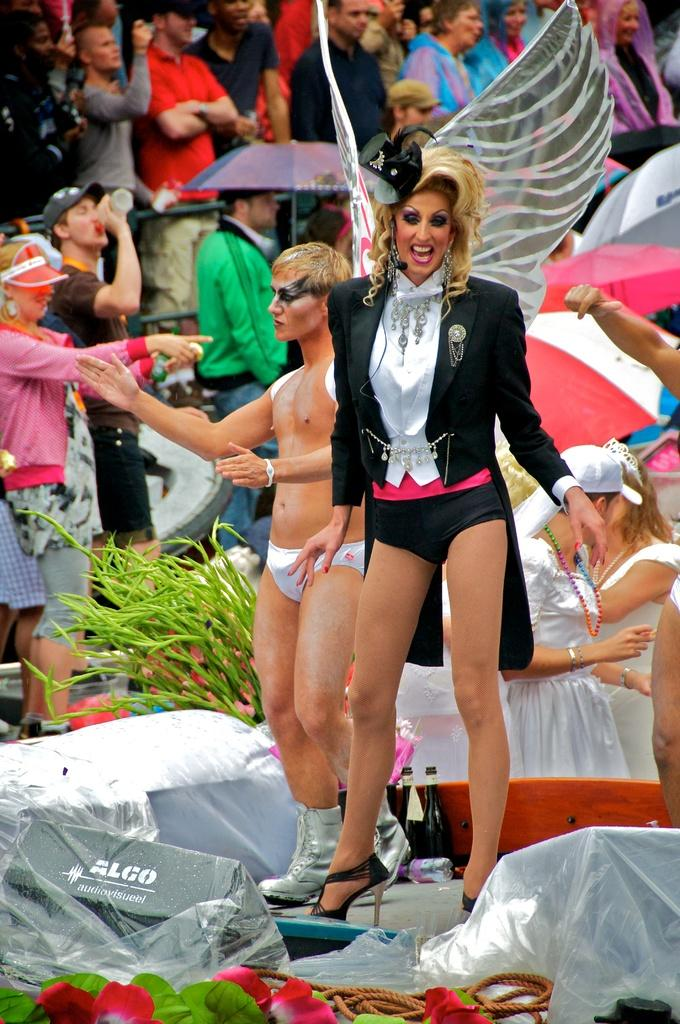How many people are present in the image? There are people in the image, but the exact number is not specified. What are some of the people holding in the image? Some people are holding objects, but the specific objects are not mentioned. What type of containers can be seen in the image? There are bottles in the image. What type of flora is present in the image? There are flowers and a plant in the image. What type of protective gear is visible in the image? There are umbrellas in the image. What type of material is present in the image? There is a rope in the image. What other unspecified objects are present in the image? There are other unspecified objects in the image. What type of crow can be seen perched on the plant in the image? There is no crow present in the image; only people, bottles, flowers, umbrellas, a rope, and other unspecified objects are mentioned. 